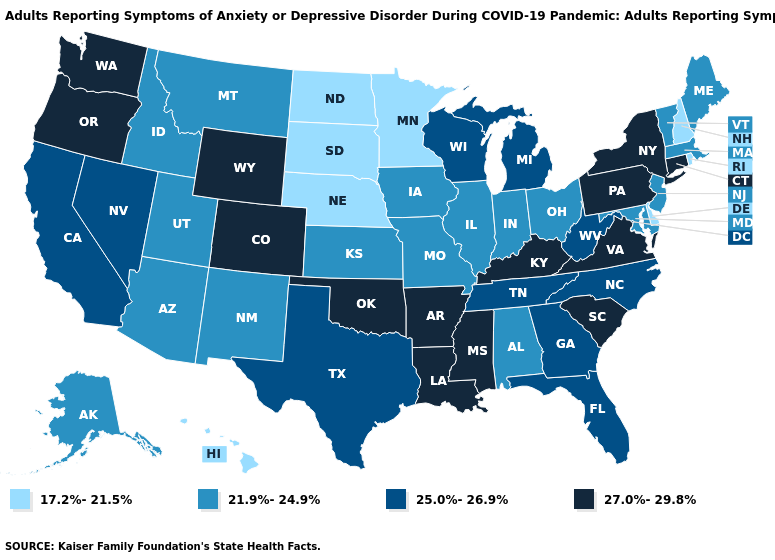What is the lowest value in states that border Virginia?
Write a very short answer. 21.9%-24.9%. What is the value of Oregon?
Keep it brief. 27.0%-29.8%. What is the value of Vermont?
Short answer required. 21.9%-24.9%. Does Nebraska have a higher value than Kansas?
Be succinct. No. Does Massachusetts have the lowest value in the USA?
Give a very brief answer. No. What is the value of Nebraska?
Keep it brief. 17.2%-21.5%. What is the lowest value in the USA?
Concise answer only. 17.2%-21.5%. What is the value of Nevada?
Keep it brief. 25.0%-26.9%. Name the states that have a value in the range 17.2%-21.5%?
Keep it brief. Delaware, Hawaii, Minnesota, Nebraska, New Hampshire, North Dakota, Rhode Island, South Dakota. What is the value of Florida?
Short answer required. 25.0%-26.9%. What is the highest value in the MidWest ?
Short answer required. 25.0%-26.9%. Does South Carolina have the same value as Maryland?
Keep it brief. No. Does the map have missing data?
Keep it brief. No. Name the states that have a value in the range 17.2%-21.5%?
Short answer required. Delaware, Hawaii, Minnesota, Nebraska, New Hampshire, North Dakota, Rhode Island, South Dakota. What is the value of Georgia?
Keep it brief. 25.0%-26.9%. 